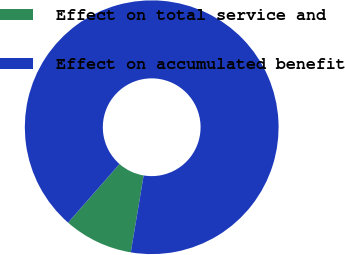Convert chart. <chart><loc_0><loc_0><loc_500><loc_500><pie_chart><fcel>Effect on total service and<fcel>Effect on accumulated benefit<nl><fcel>8.82%<fcel>91.18%<nl></chart> 